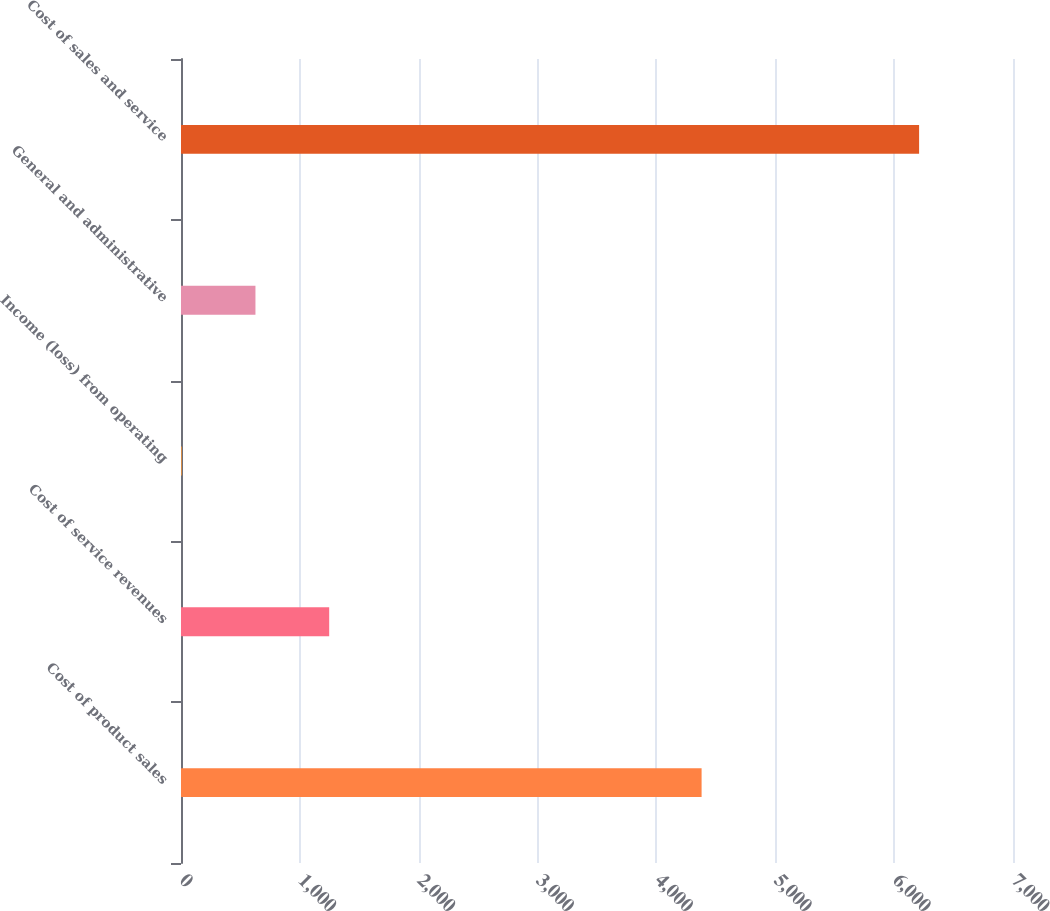Convert chart to OTSL. <chart><loc_0><loc_0><loc_500><loc_500><bar_chart><fcel>Cost of product sales<fcel>Cost of service revenues<fcel>Income (loss) from operating<fcel>General and administrative<fcel>Cost of sales and service<nl><fcel>4380<fcel>1246.8<fcel>6<fcel>626.4<fcel>6210<nl></chart> 